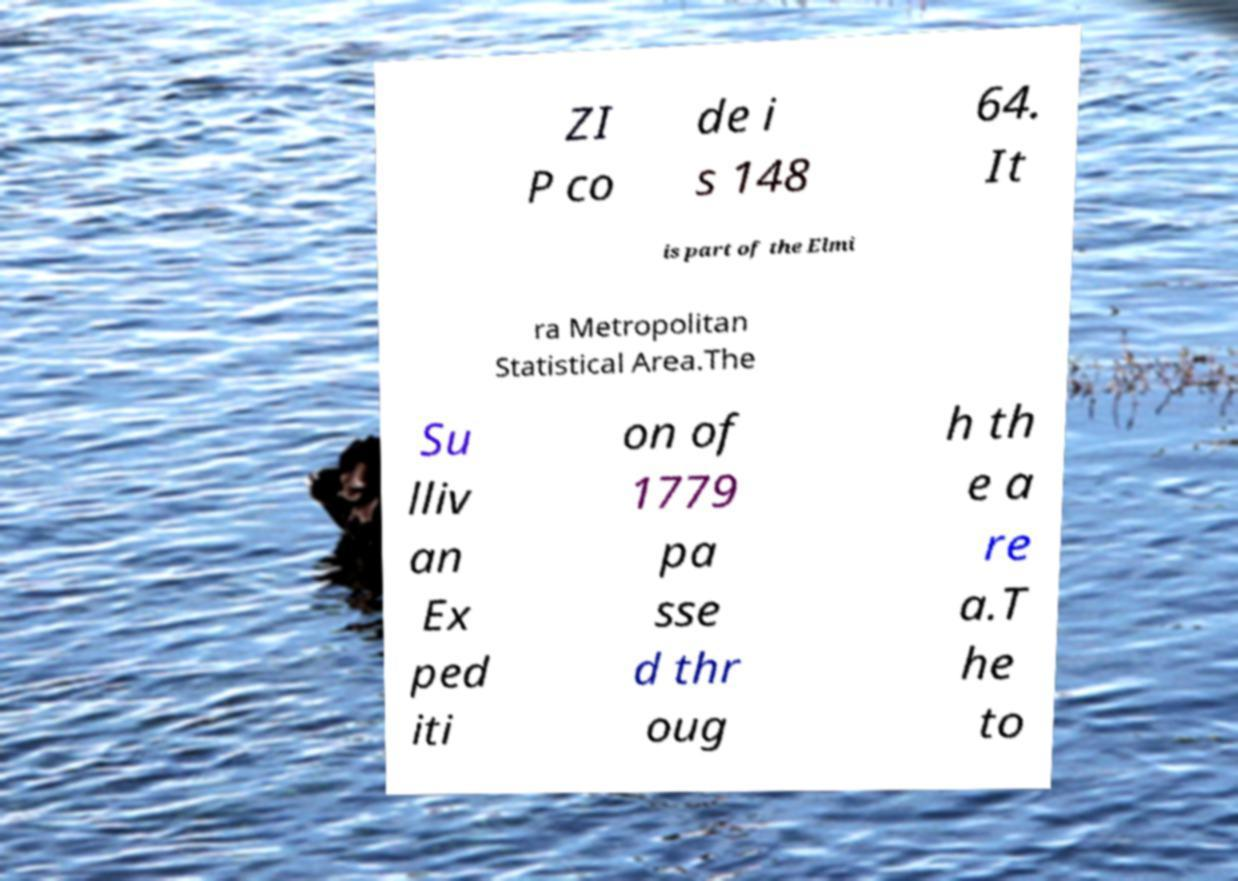Please identify and transcribe the text found in this image. ZI P co de i s 148 64. It is part of the Elmi ra Metropolitan Statistical Area.The Su lliv an Ex ped iti on of 1779 pa sse d thr oug h th e a re a.T he to 